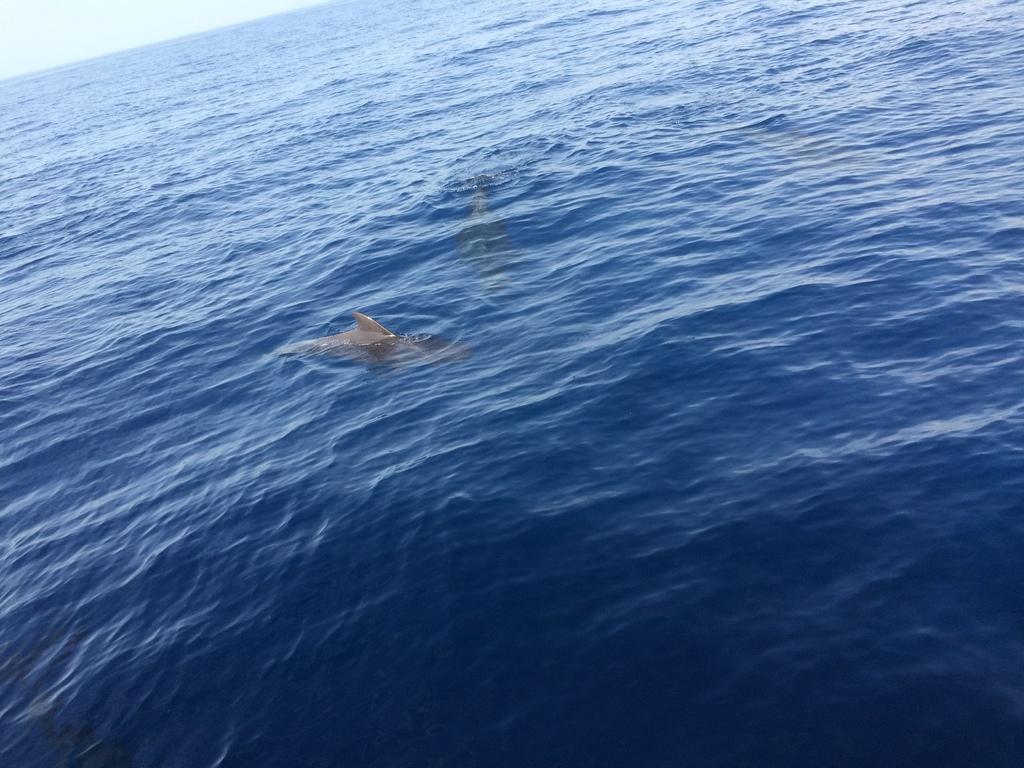How would you summarize this image in a sentence or two? In this image we can see dolphins in the water and sky in the background. 